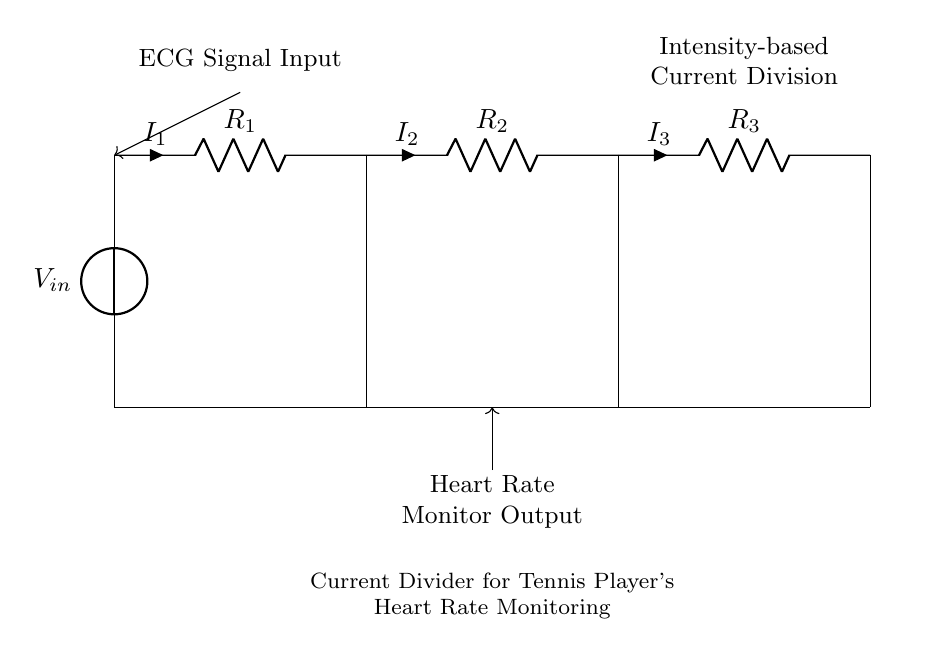What is the input voltage of the circuit? The input voltage is labeled as \( V_{in} \), which is indicated at the top of the circuit in the voltage source.
Answer: \( V_{in} \) What do the resistors \( R_1 \), \( R_2 \), and \( R_3 \) signify in this circuit? \( R_1 \), \( R_2 \), and \( R_3 \) are resistors, each representing different branches in the current divider circuit for measuring heart rate.
Answer: Resistors What is the purpose of the current divider circuit in this diagram? The current divider circuit is designed to split input current into multiple branches, allowing for heart rate monitoring during intense tennis matches.
Answer: Heart rate monitoring Which resistor has the highest current flowing through it? The current flowing through each resistor depends on its resistance value and configuration; however, without specific values, it typically would be the resistor with the lowest resistance.
Answer: Lowest resistance If the total current entering \( V_{in} \) is five Amperes, how would you distribute the current among the resistors? To find the distribution of current among \( R_1, R_2, \) and \( R_3 \), you would use the current divider formula, which divides current inversely based on resistance values if they are known. For specific answers, the resistance values are needed.
Answer: Requires resistance values What happens if one resistor fails in this current divider circuit? If one resistor fails, it will affect the division of current in the remaining resistors, potentially leading to higher currents in those branches and could alter the heart rate monitoring output.
Answer: Affects current division 